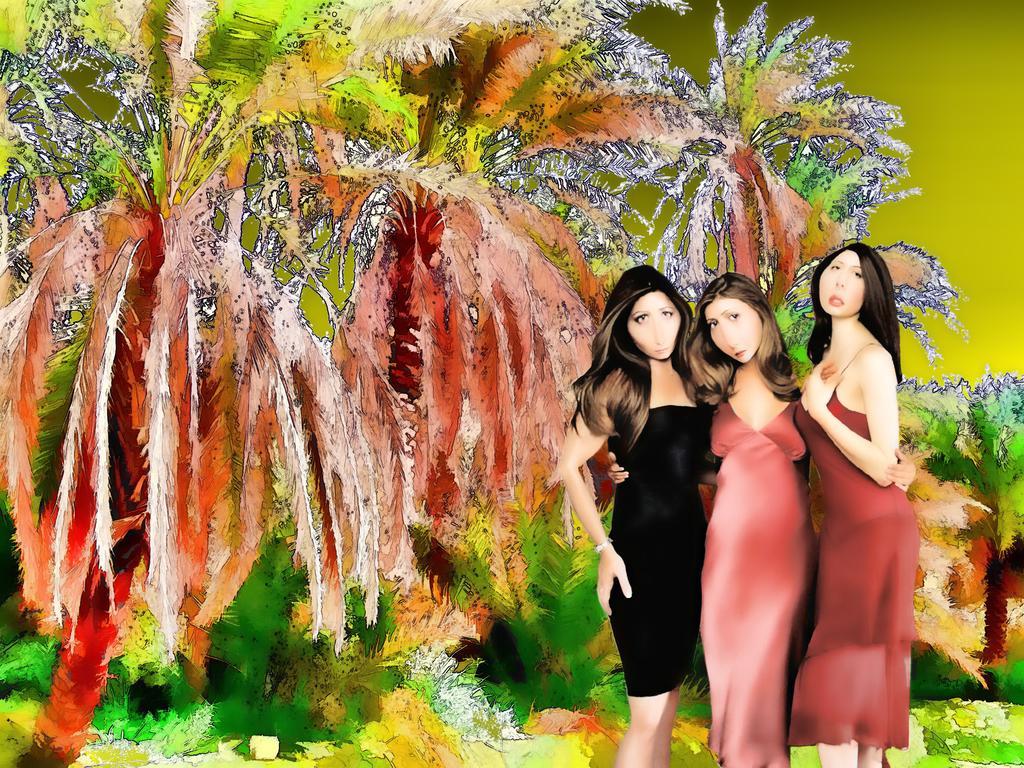Could you give a brief overview of what you see in this image? It is a painting. In the image in the center, we can see three persons are standing. In the background we can see trees. 